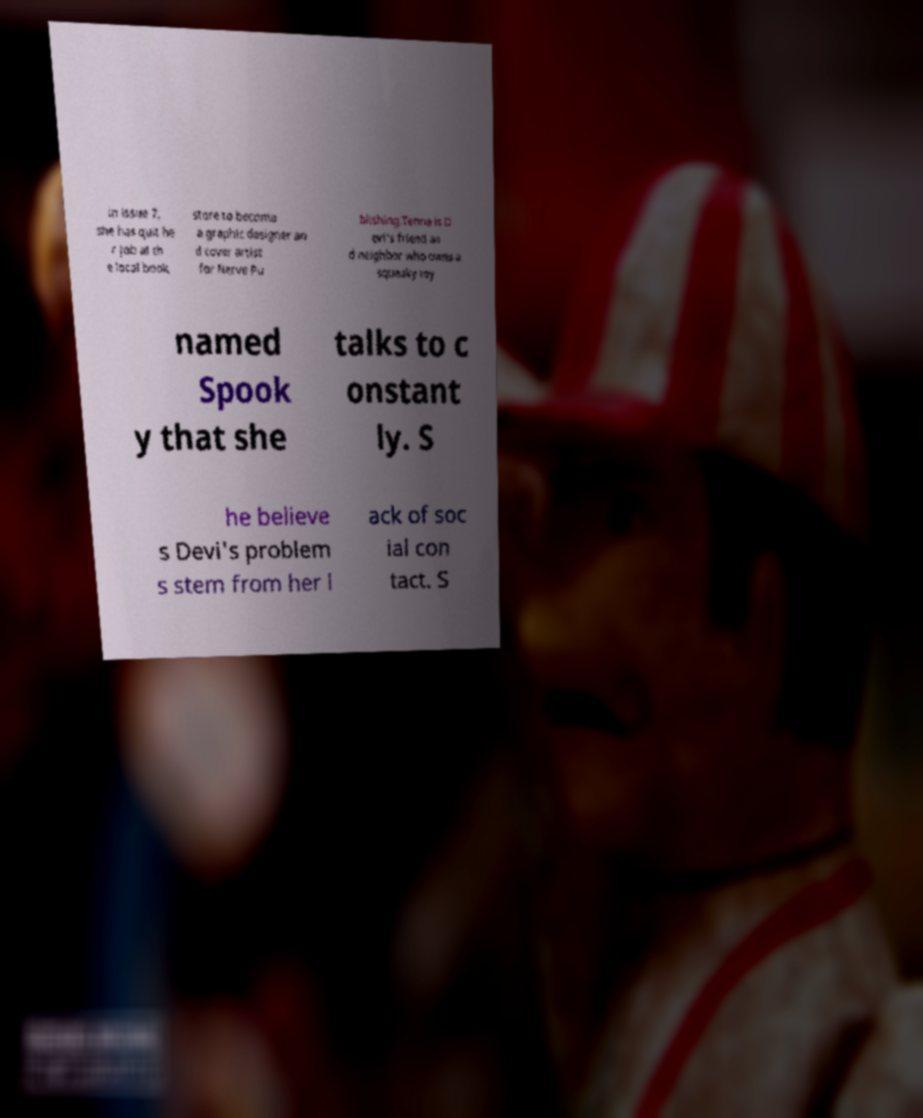There's text embedded in this image that I need extracted. Can you transcribe it verbatim? in issue 7, she has quit he r job at th e local book store to become a graphic designer an d cover artist for Nerve Pu blishing.Tenna is D evi's friend an d neighbor who owns a squeaky toy named Spook y that she talks to c onstant ly. S he believe s Devi's problem s stem from her l ack of soc ial con tact. S 